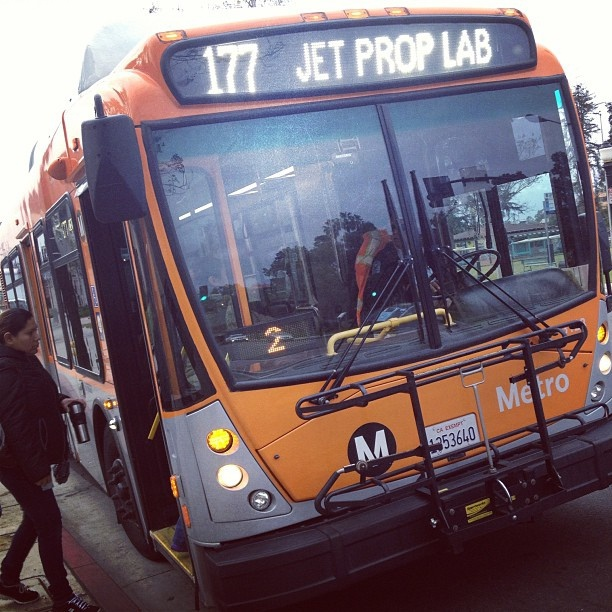Describe the objects in this image and their specific colors. I can see bus in white, black, gray, and darkgray tones, people in white, black, and gray tones, people in white, black, navy, gray, and purple tones, and people in white, gray, and black tones in this image. 